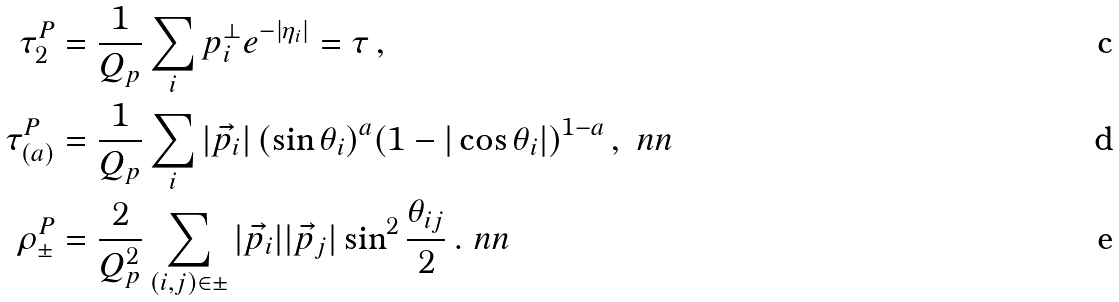<formula> <loc_0><loc_0><loc_500><loc_500>\tau _ { 2 } ^ { P } & = \frac { 1 } { Q _ { p } } \sum _ { i } p _ { i } ^ { \perp } e ^ { - | \eta _ { i } | } = \tau \, , \\ \tau _ { ( a ) } ^ { P } & = \frac { 1 } { Q _ { p } } \sum _ { i } | \vec { p } _ { i } | \, ( \sin \theta _ { i } ) ^ { a } ( 1 - | \cos \theta _ { i } | ) ^ { 1 - a } \, , \ n n \\ \rho _ { \pm } ^ { P } & = \frac { 2 } { Q _ { p } ^ { 2 } } \sum _ { ( i , j ) \in \pm } | \vec { p } _ { i } | | \vec { p } _ { j } | \sin ^ { 2 } \frac { \theta _ { i j } } { 2 } \, . \ n n</formula> 